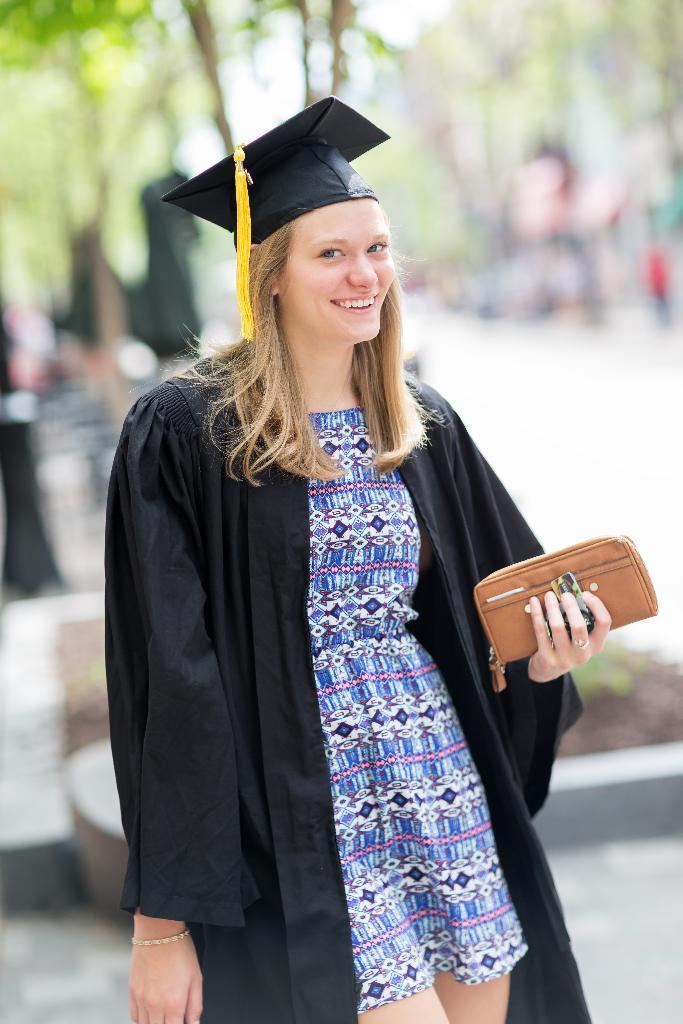Can you describe this image briefly? In this picture I can see a woman smiling and also she is holding the purse with her hand, in the middle. In the background there are trees. 